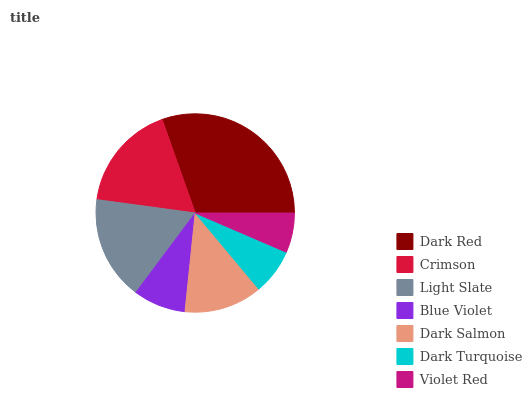Is Violet Red the minimum?
Answer yes or no. Yes. Is Dark Red the maximum?
Answer yes or no. Yes. Is Crimson the minimum?
Answer yes or no. No. Is Crimson the maximum?
Answer yes or no. No. Is Dark Red greater than Crimson?
Answer yes or no. Yes. Is Crimson less than Dark Red?
Answer yes or no. Yes. Is Crimson greater than Dark Red?
Answer yes or no. No. Is Dark Red less than Crimson?
Answer yes or no. No. Is Dark Salmon the high median?
Answer yes or no. Yes. Is Dark Salmon the low median?
Answer yes or no. Yes. Is Crimson the high median?
Answer yes or no. No. Is Dark Turquoise the low median?
Answer yes or no. No. 